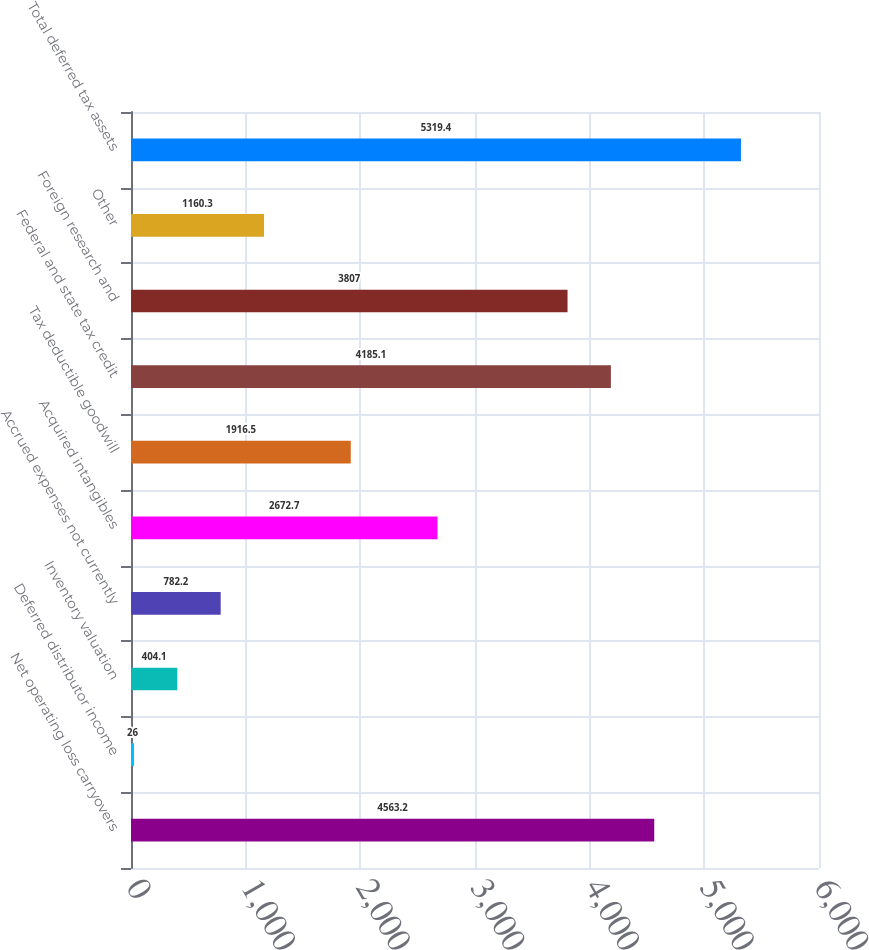<chart> <loc_0><loc_0><loc_500><loc_500><bar_chart><fcel>Net operating loss carryovers<fcel>Deferred distributor income<fcel>Inventory valuation<fcel>Accrued expenses not currently<fcel>Acquired intangibles<fcel>Tax deductible goodwill<fcel>Federal and state tax credit<fcel>Foreign research and<fcel>Other<fcel>Total deferred tax assets<nl><fcel>4563.2<fcel>26<fcel>404.1<fcel>782.2<fcel>2672.7<fcel>1916.5<fcel>4185.1<fcel>3807<fcel>1160.3<fcel>5319.4<nl></chart> 